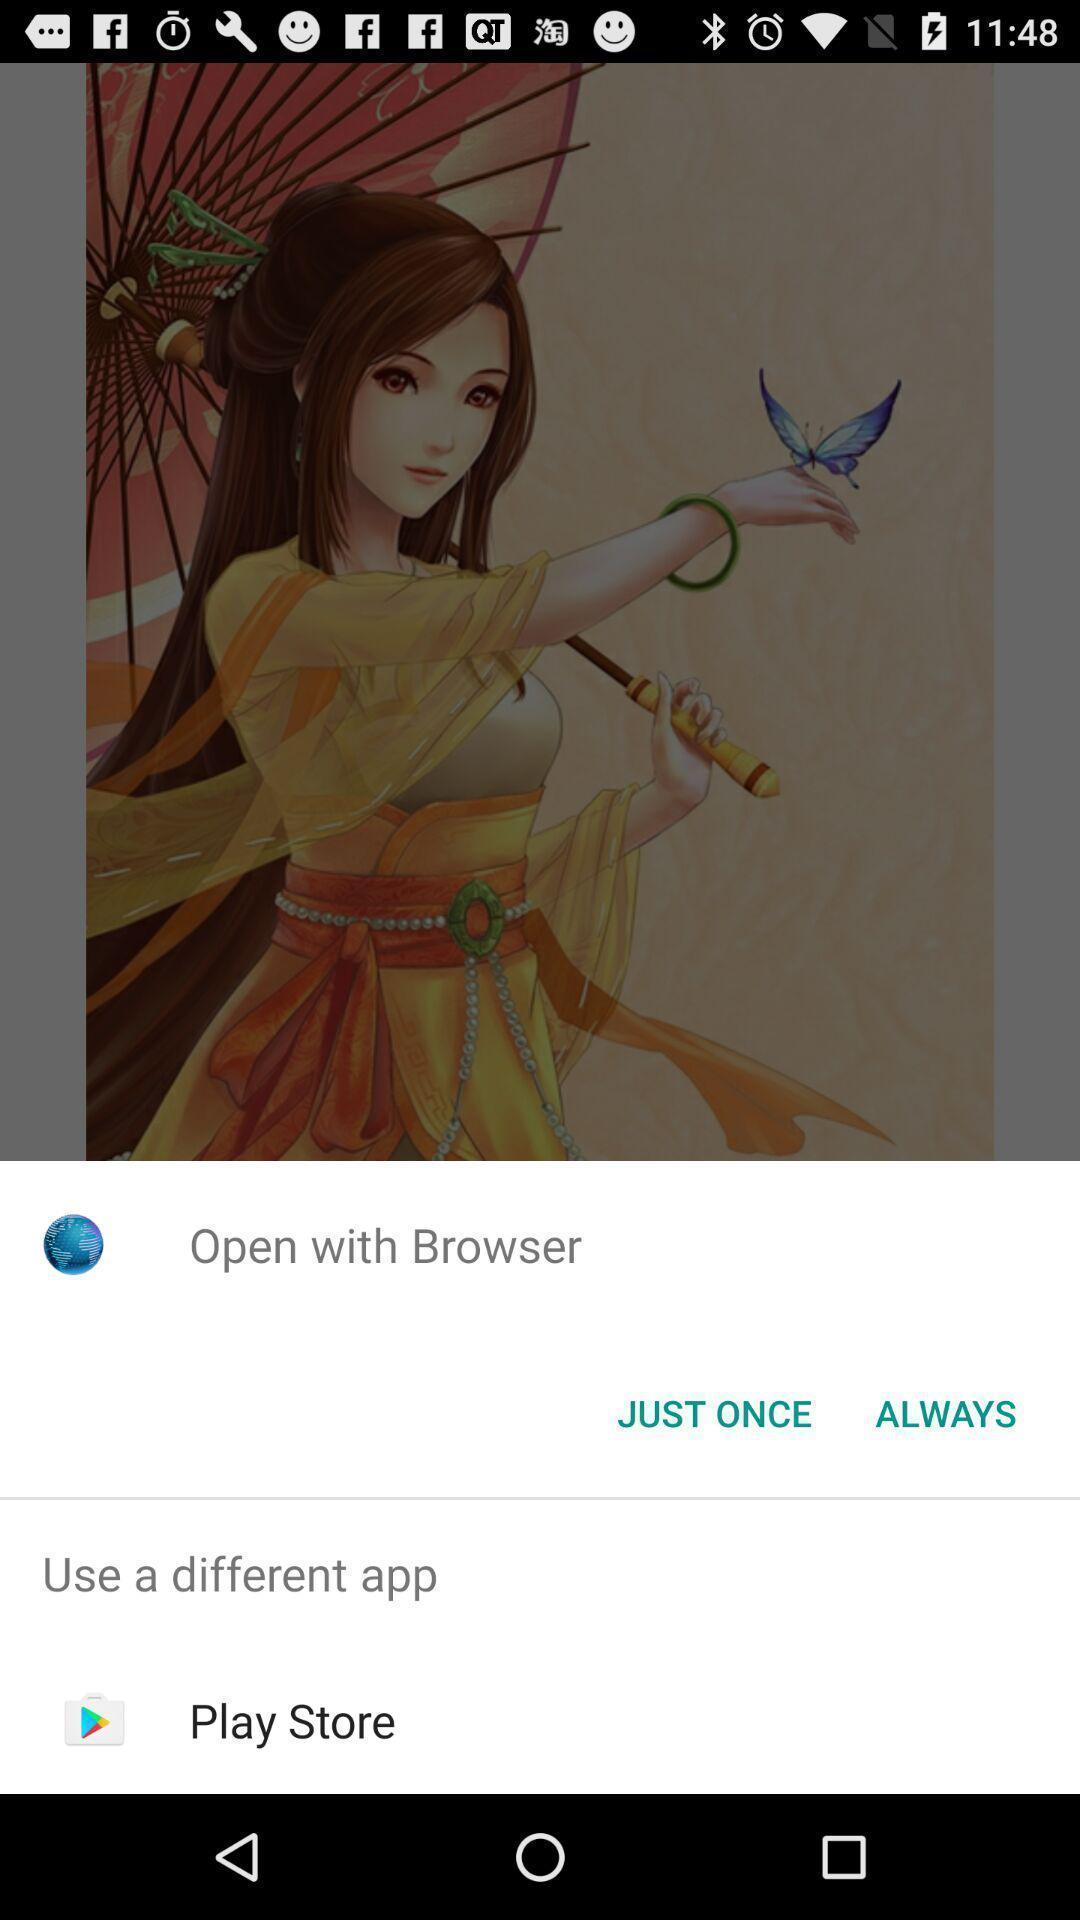Describe the content in this image. Pop up showing to open the app in the browser. 